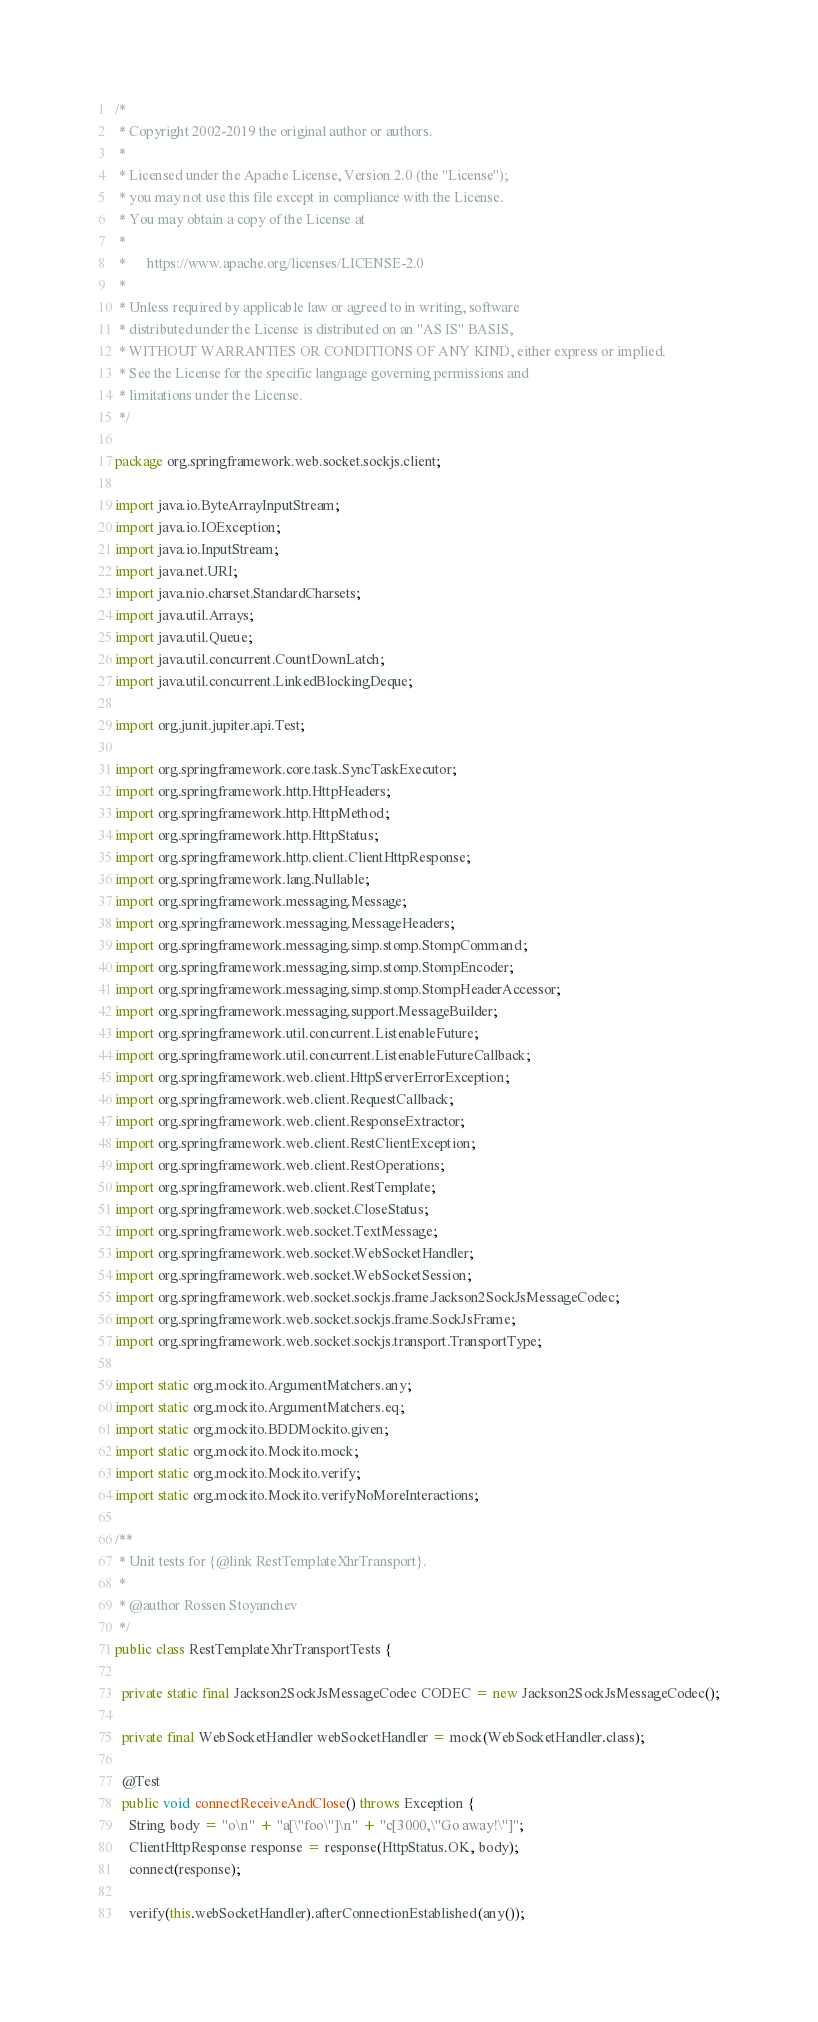<code> <loc_0><loc_0><loc_500><loc_500><_Java_>/*
 * Copyright 2002-2019 the original author or authors.
 *
 * Licensed under the Apache License, Version 2.0 (the "License");
 * you may not use this file except in compliance with the License.
 * You may obtain a copy of the License at
 *
 *      https://www.apache.org/licenses/LICENSE-2.0
 *
 * Unless required by applicable law or agreed to in writing, software
 * distributed under the License is distributed on an "AS IS" BASIS,
 * WITHOUT WARRANTIES OR CONDITIONS OF ANY KIND, either express or implied.
 * See the License for the specific language governing permissions and
 * limitations under the License.
 */

package org.springframework.web.socket.sockjs.client;

import java.io.ByteArrayInputStream;
import java.io.IOException;
import java.io.InputStream;
import java.net.URI;
import java.nio.charset.StandardCharsets;
import java.util.Arrays;
import java.util.Queue;
import java.util.concurrent.CountDownLatch;
import java.util.concurrent.LinkedBlockingDeque;

import org.junit.jupiter.api.Test;

import org.springframework.core.task.SyncTaskExecutor;
import org.springframework.http.HttpHeaders;
import org.springframework.http.HttpMethod;
import org.springframework.http.HttpStatus;
import org.springframework.http.client.ClientHttpResponse;
import org.springframework.lang.Nullable;
import org.springframework.messaging.Message;
import org.springframework.messaging.MessageHeaders;
import org.springframework.messaging.simp.stomp.StompCommand;
import org.springframework.messaging.simp.stomp.StompEncoder;
import org.springframework.messaging.simp.stomp.StompHeaderAccessor;
import org.springframework.messaging.support.MessageBuilder;
import org.springframework.util.concurrent.ListenableFuture;
import org.springframework.util.concurrent.ListenableFutureCallback;
import org.springframework.web.client.HttpServerErrorException;
import org.springframework.web.client.RequestCallback;
import org.springframework.web.client.ResponseExtractor;
import org.springframework.web.client.RestClientException;
import org.springframework.web.client.RestOperations;
import org.springframework.web.client.RestTemplate;
import org.springframework.web.socket.CloseStatus;
import org.springframework.web.socket.TextMessage;
import org.springframework.web.socket.WebSocketHandler;
import org.springframework.web.socket.WebSocketSession;
import org.springframework.web.socket.sockjs.frame.Jackson2SockJsMessageCodec;
import org.springframework.web.socket.sockjs.frame.SockJsFrame;
import org.springframework.web.socket.sockjs.transport.TransportType;

import static org.mockito.ArgumentMatchers.any;
import static org.mockito.ArgumentMatchers.eq;
import static org.mockito.BDDMockito.given;
import static org.mockito.Mockito.mock;
import static org.mockito.Mockito.verify;
import static org.mockito.Mockito.verifyNoMoreInteractions;

/**
 * Unit tests for {@link RestTemplateXhrTransport}.
 *
 * @author Rossen Stoyanchev
 */
public class RestTemplateXhrTransportTests {

  private static final Jackson2SockJsMessageCodec CODEC = new Jackson2SockJsMessageCodec();

  private final WebSocketHandler webSocketHandler = mock(WebSocketHandler.class);

  @Test
  public void connectReceiveAndClose() throws Exception {
    String body = "o\n" + "a[\"foo\"]\n" + "c[3000,\"Go away!\"]";
    ClientHttpResponse response = response(HttpStatus.OK, body);
    connect(response);

    verify(this.webSocketHandler).afterConnectionEstablished(any());</code> 